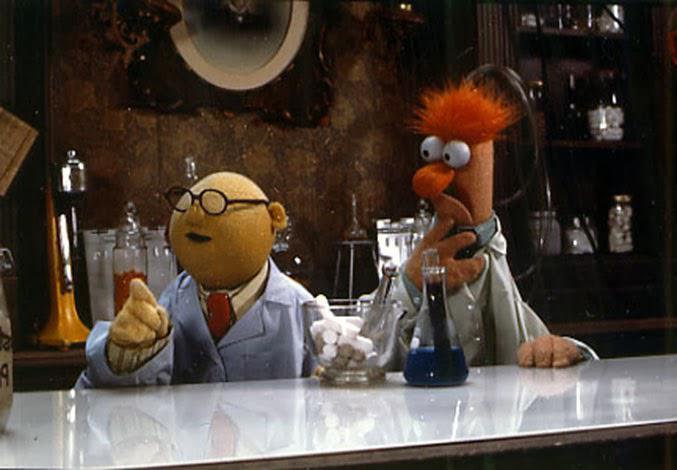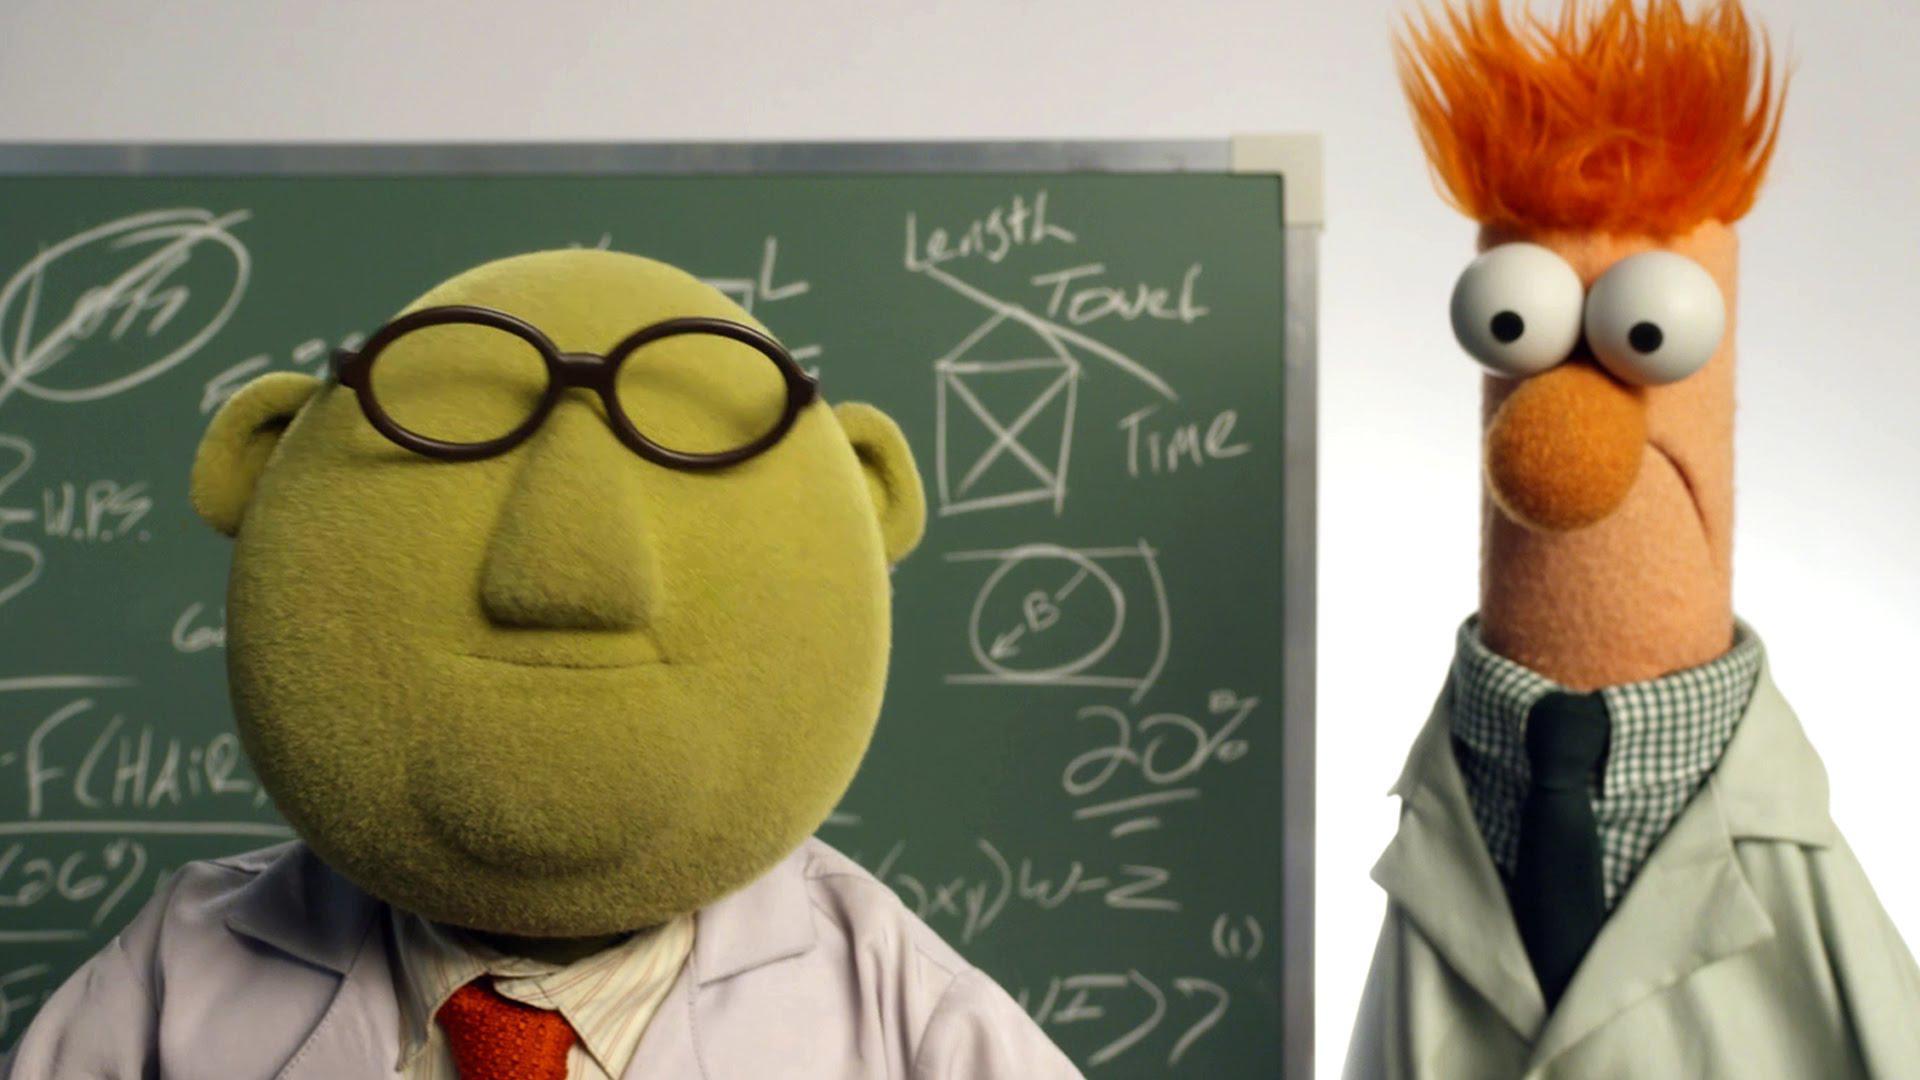The first image is the image on the left, the second image is the image on the right. Analyze the images presented: Is the assertion "Each image has the same two muppets without any other muppets." valid? Answer yes or no. Yes. 